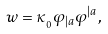<formula> <loc_0><loc_0><loc_500><loc_500>w = \kappa _ { _ { 0 } } \varphi _ { | a } \varphi ^ { | a } \, ,</formula> 